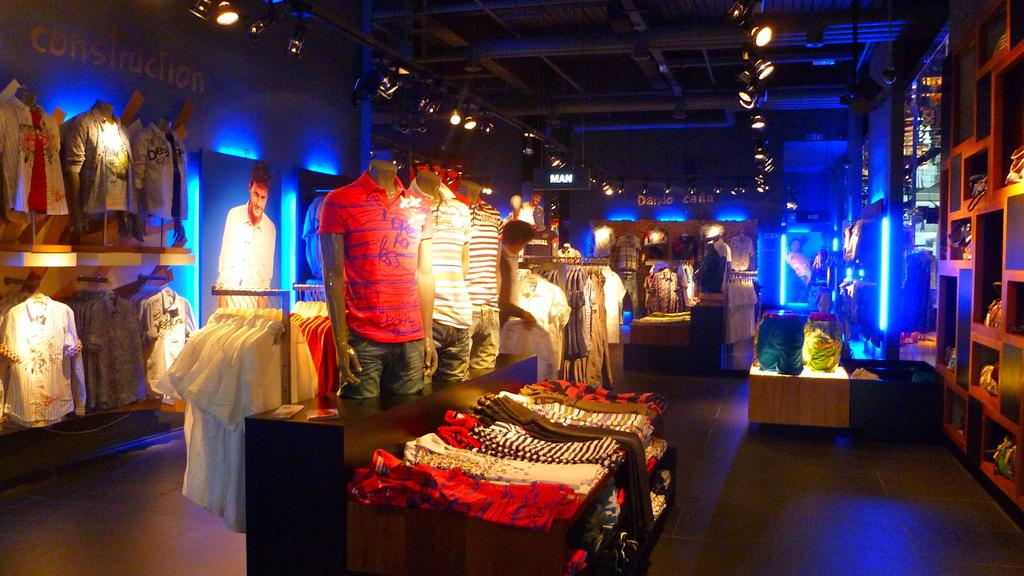Where was the image taken? The image was taken in a store. What can be seen in the middle of the image? There are many clothes in the middle of the image. What type of lighting is present in the image? There are lights at the top of the image. How many protesters can be seen holding fangs in the image? There are no protesters or fangs present in the image; it features clothes in a store with lights at the top. 